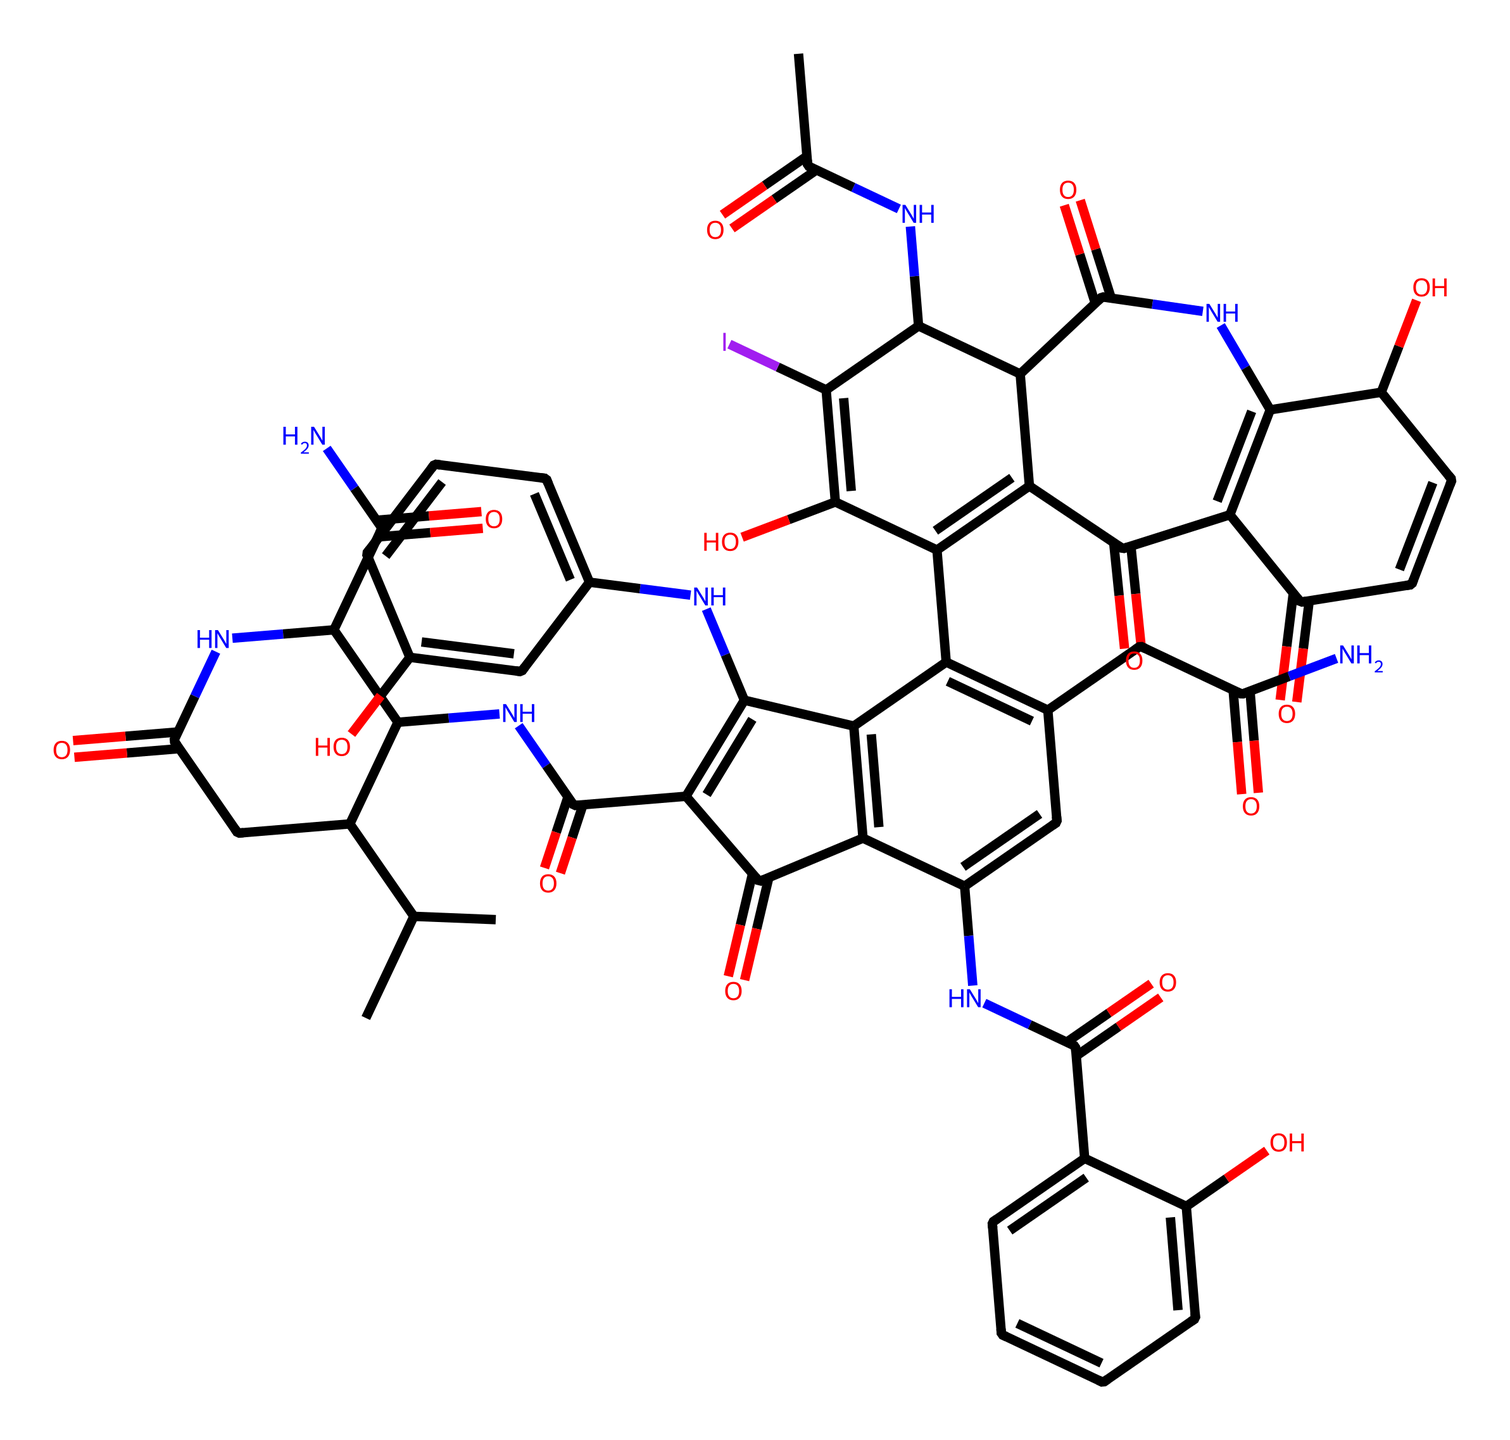What is the molecular formula of vancomycin based on its structure? By analyzing the chemical structure derived from the SMILES representation, we can count the number of carbon (C), hydrogen (H), nitrogen (N), and oxygen (O) atoms present in the molecule. This gives us the molecular formula.
Answer: C66H75Cl2N9O24 How many rings are present in the structure of vancomycin? In the SMILES representation, we can identify the cyclic structures indicated by the numbers in the notation. By examining these indicators, we determine that there are multiple interconnected rings in the molecule.
Answer: 5 Which functional groups are predominantly present in vancomycin? The chemical structure can exhibit key functional groups such as amides (indicated by N-C=O groups), alcohols (indicated by -OH groups), and possibly others like ethers or chlorides. By systematically analyzing the structure, we can identify the major functional groups.
Answer: amide, hydroxyl What is the primary target mechanism of vancomycin against gram-positive bacteria? The mechanism is primarily through inhibiting cell wall synthesis in gram-positive bacteria, which can be inferred from the presence of components interacting with peptidoglycan layer formation.
Answer: cell wall synthesis How many nitrogen atoms are present in the vancomycin structure? Looking through the SMILES representation, we can count the instances of nitrogen (N) atoms to determine the total number of nitrogen present in the molecule.
Answer: 9 